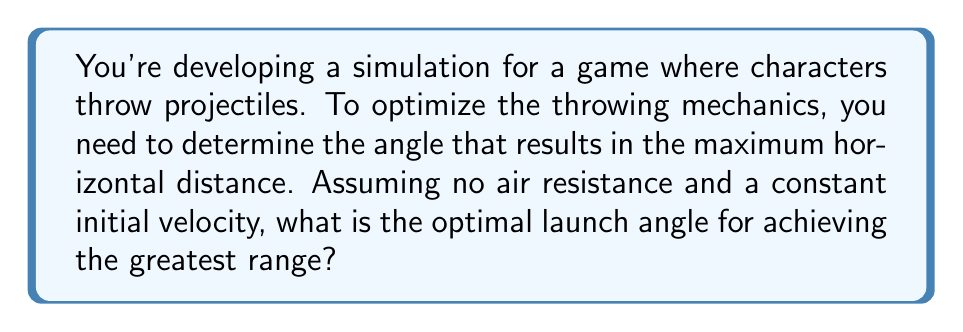Can you solve this math problem? Let's approach this step-by-step:

1) The range (R) of a projectile launched from ground level is given by the equation:

   $$R = \frac{v^2 \sin(2\theta)}{g}$$

   Where:
   - $v$ is the initial velocity
   - $\theta$ is the launch angle
   - $g$ is the acceleration due to gravity

2) To find the maximum range, we need to maximize $\sin(2\theta)$.

3) The sine function reaches its maximum value of 1 when its argument is 90°.

4) So, we want:

   $$2\theta = 90°$$

5) Solving for $\theta$:

   $$\theta = 45°$$

6) We can verify this mathematically:
   
   $$\frac{d}{d\theta}(\sin(2\theta)) = 2\cos(2\theta)$$

   This derivative equals zero when $2\theta = 90°$, confirming our result.

7) In the context of game development, this means that characters should throw projectiles at a 45° angle to achieve maximum distance, assuming no other factors like wind or air resistance are involved.
Answer: $45°$ 